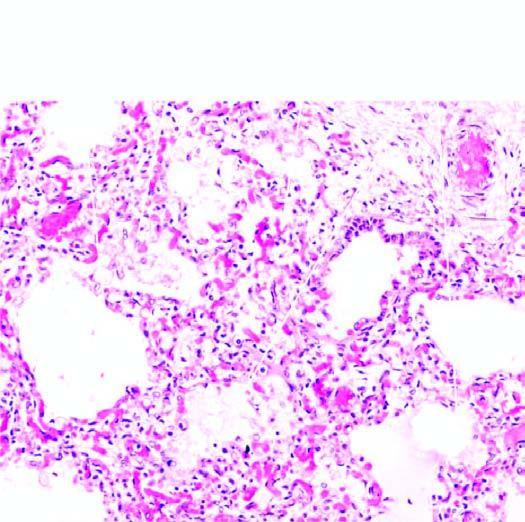do common locations and the regions of involvement contain pale oedema fluid and a few red cells?
Answer the question using a single word or phrase. No 